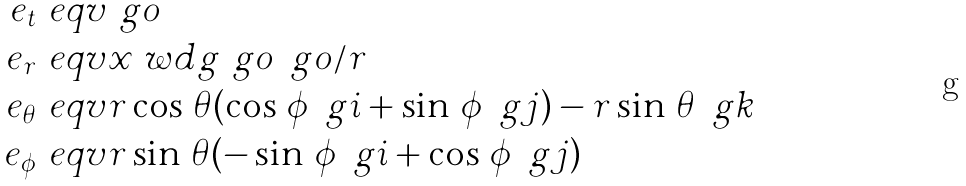Convert formula to latex. <formula><loc_0><loc_0><loc_500><loc_500>e _ { t } & \ e q v \ g o \\ e _ { r } & \ e q v x \ w d g \ g o \, \ g o / r \\ e _ { \theta } & \ e q v r \cos \, \theta ( \cos \, \phi \, \ g i + \sin \, \phi \, \ g j ) - r \sin \, \theta \, \ g k \\ e _ { \phi } & \ e q v r \sin \, \theta ( - \sin \, \phi \, \ g i + \cos \, \phi \, \ g j )</formula> 